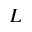Convert formula to latex. <formula><loc_0><loc_0><loc_500><loc_500>L</formula> 